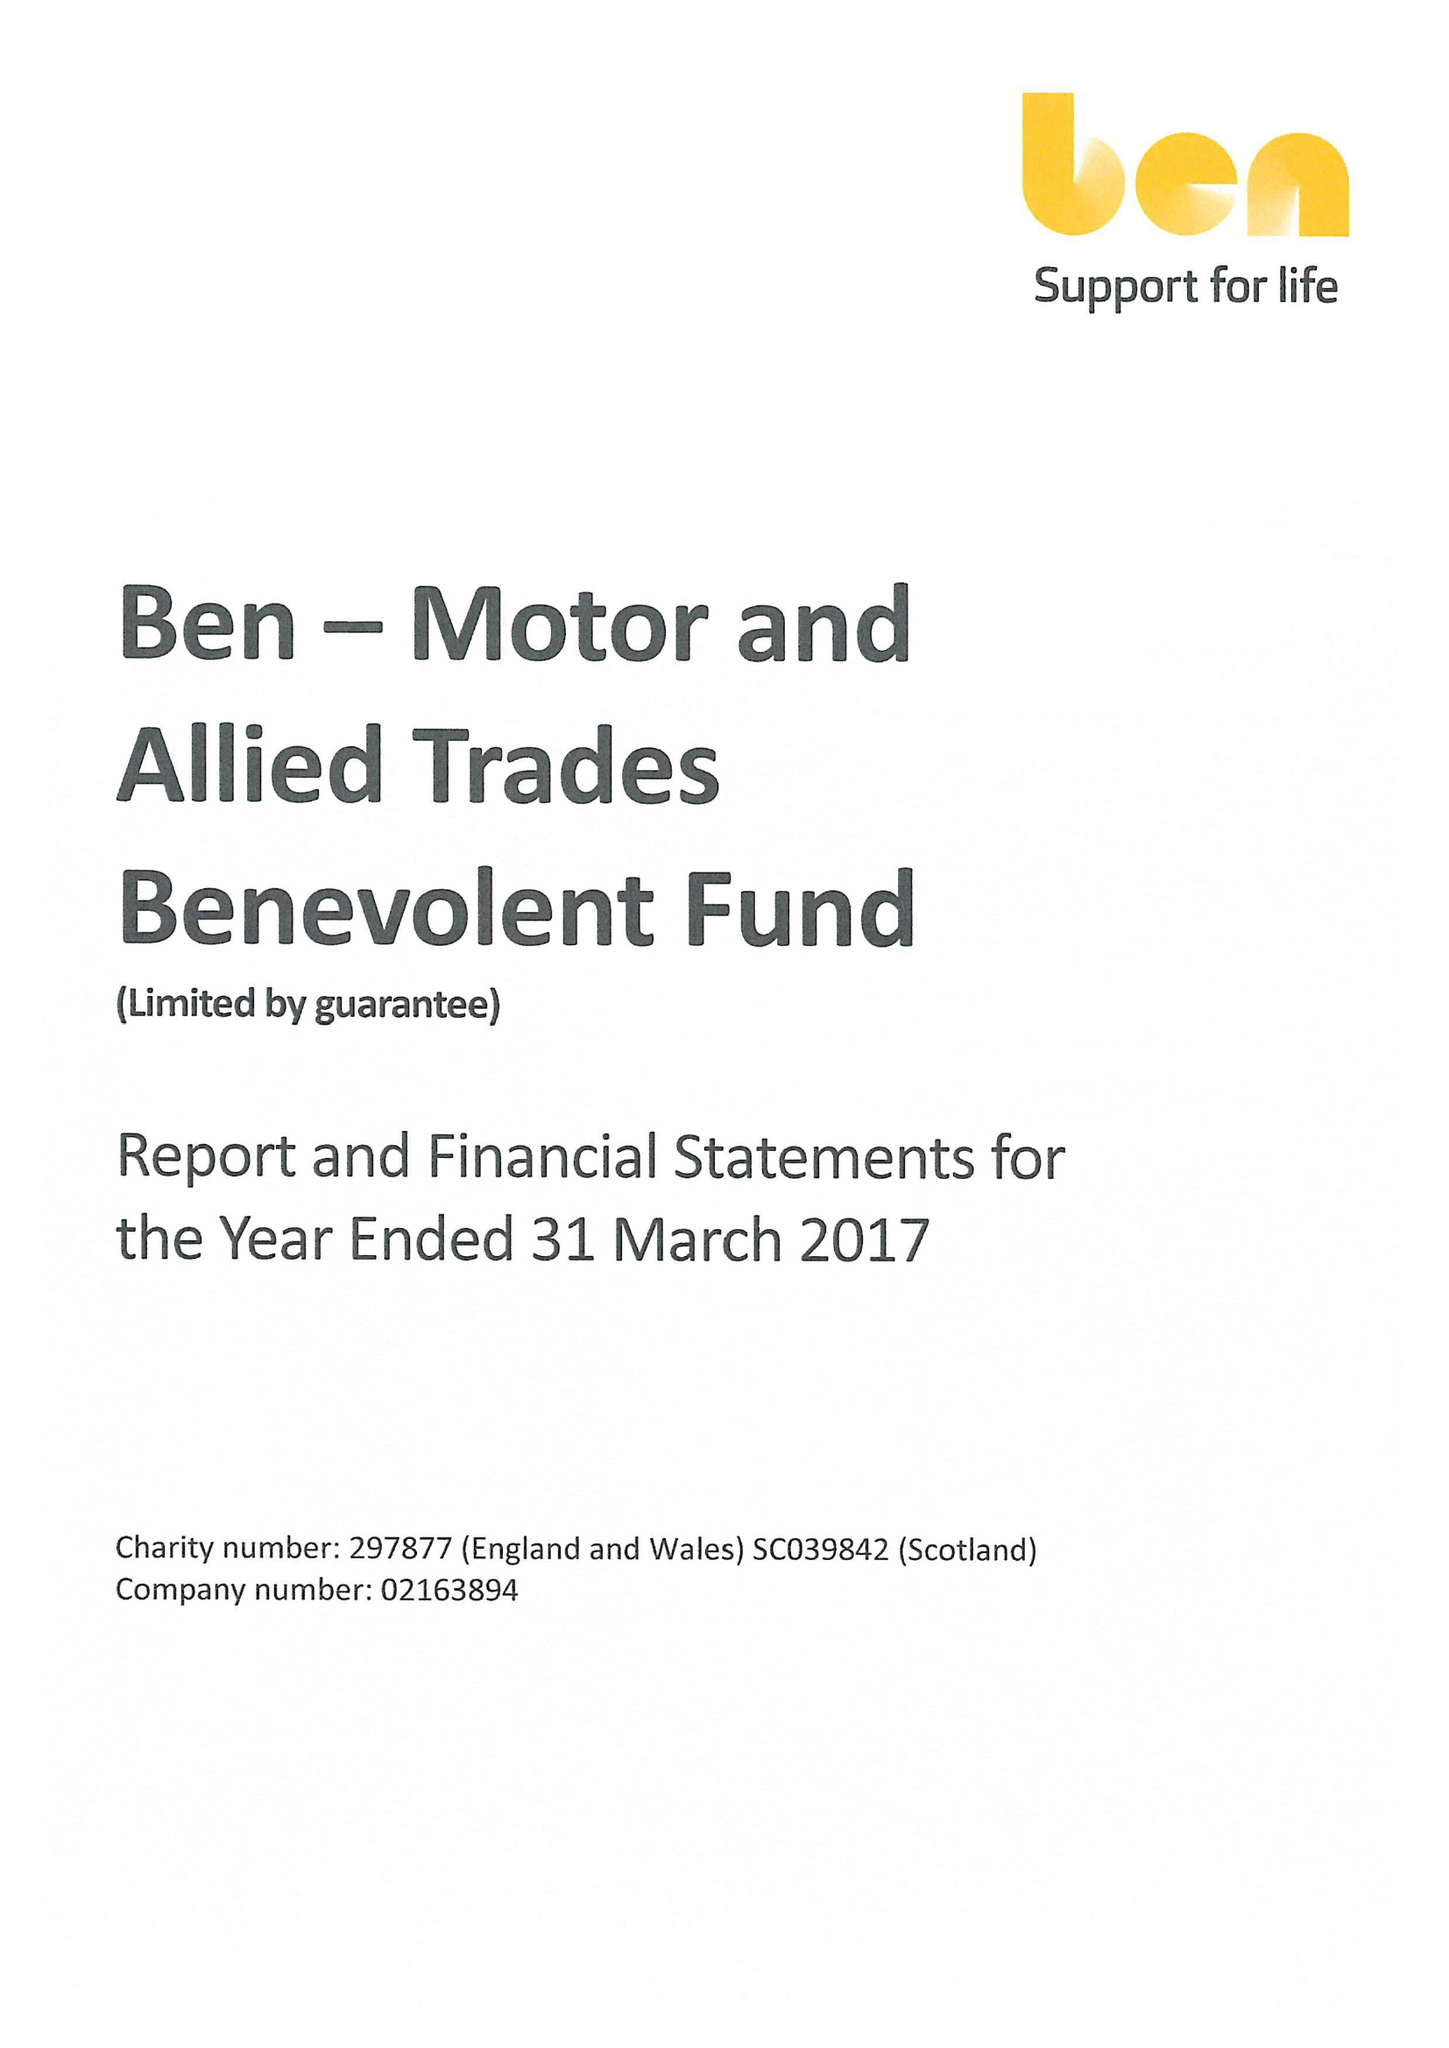What is the value for the income_annually_in_british_pounds?
Answer the question using a single word or phrase. 26331000.00 